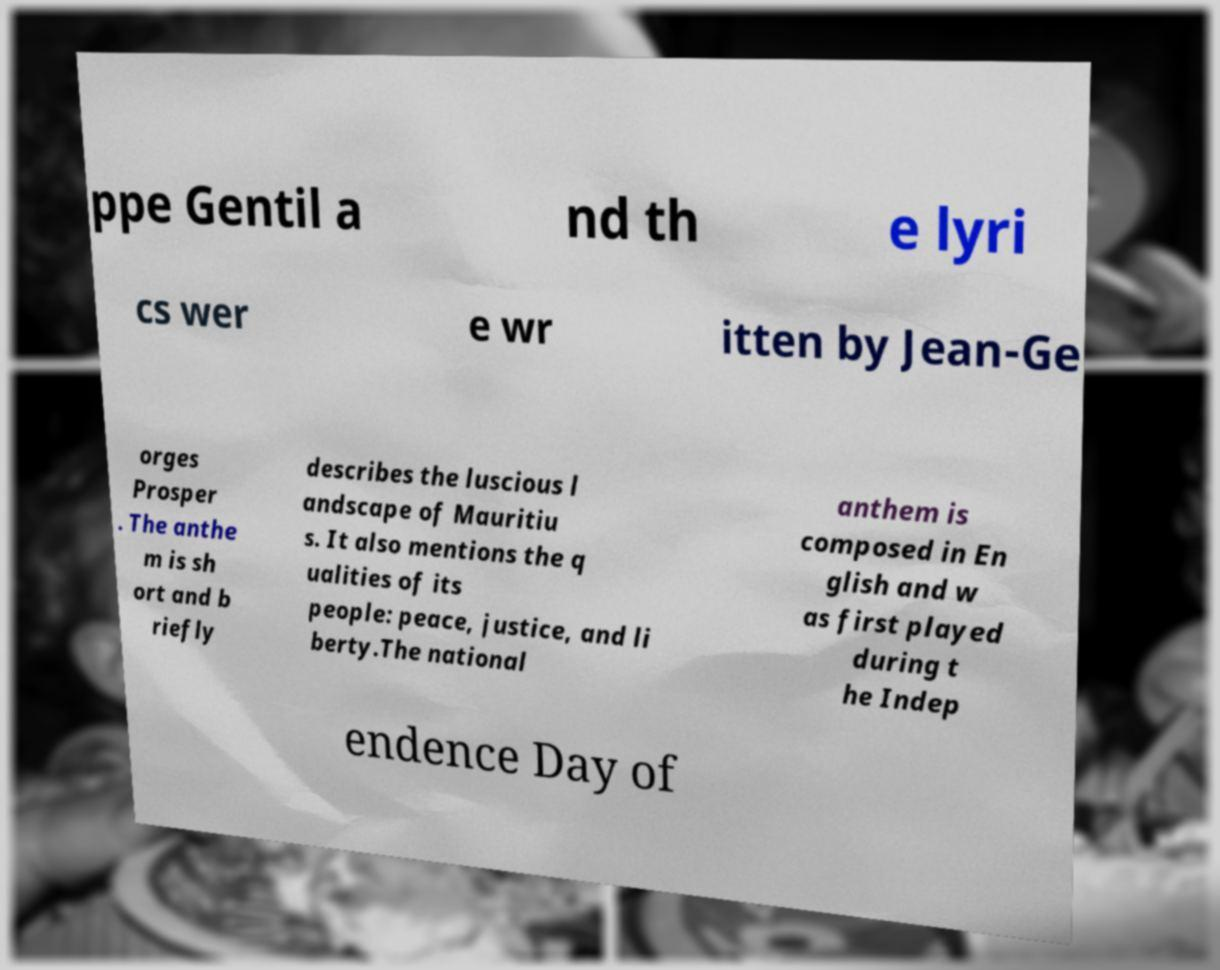Please read and relay the text visible in this image. What does it say? ppe Gentil a nd th e lyri cs wer e wr itten by Jean-Ge orges Prosper . The anthe m is sh ort and b riefly describes the luscious l andscape of Mauritiu s. It also mentions the q ualities of its people: peace, justice, and li berty.The national anthem is composed in En glish and w as first played during t he Indep endence Day of 